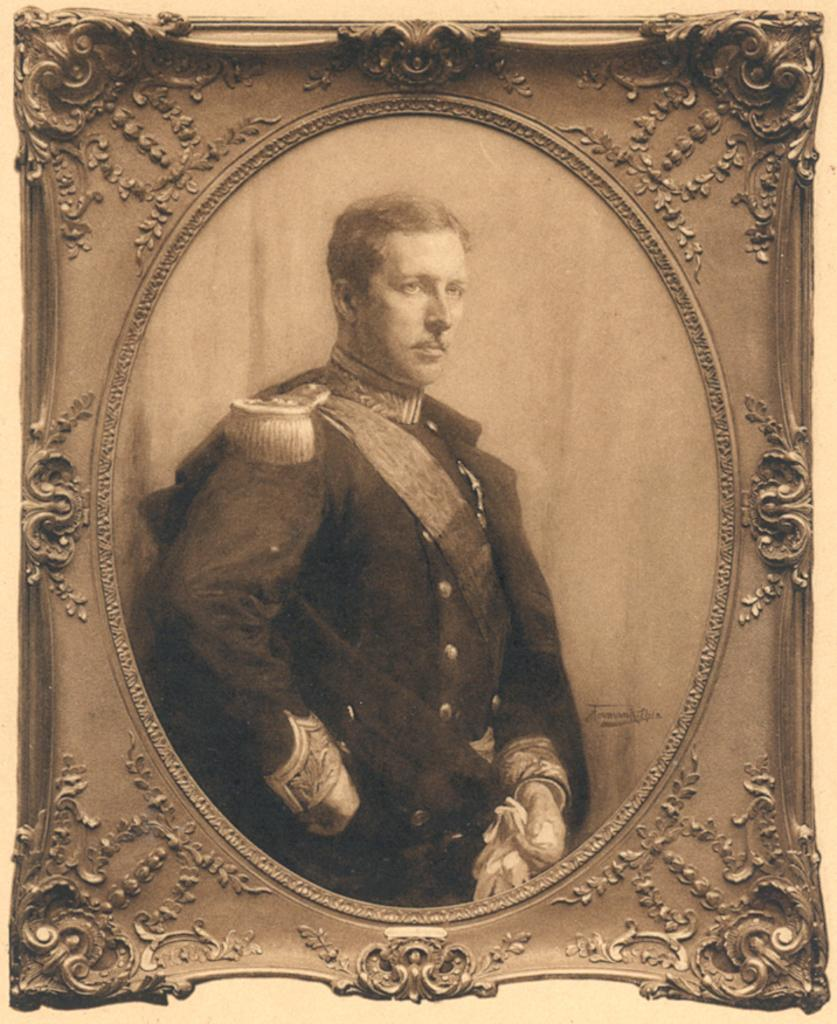What object is present in the image that typically holds a picture? There is a photo frame in the image. What can be seen inside the photo frame? The photo frame contains a picture of a person. What type of ear can be seen in the image? There is no ear present in the image; it features a photo frame with a picture of a person. 